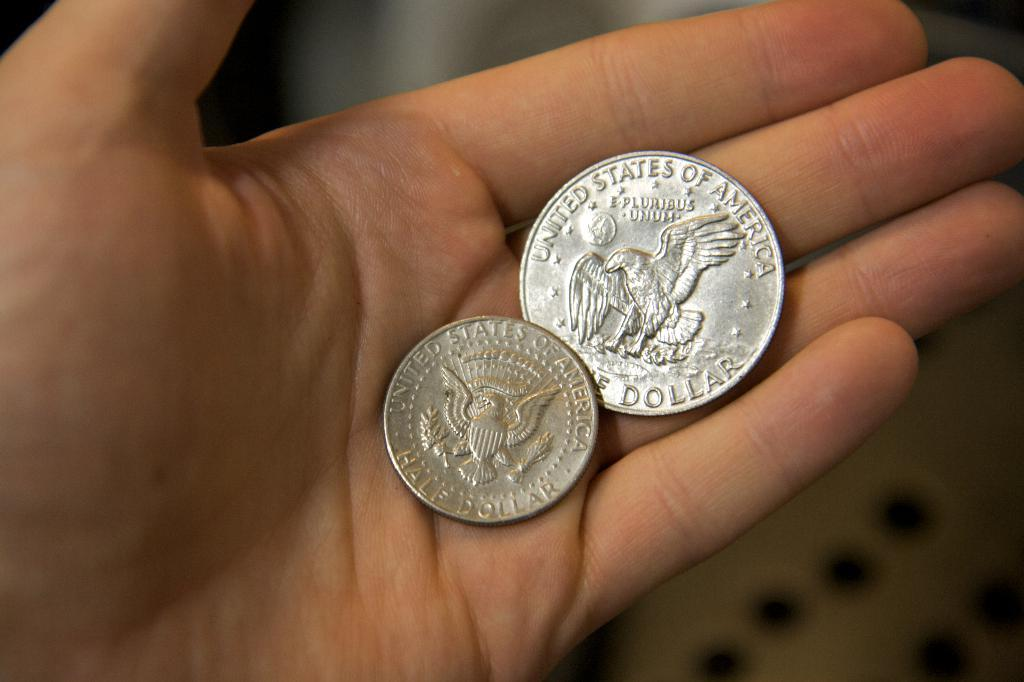<image>
Create a compact narrative representing the image presented. A man holds a half dollar coin with an engraved image of a bird. 